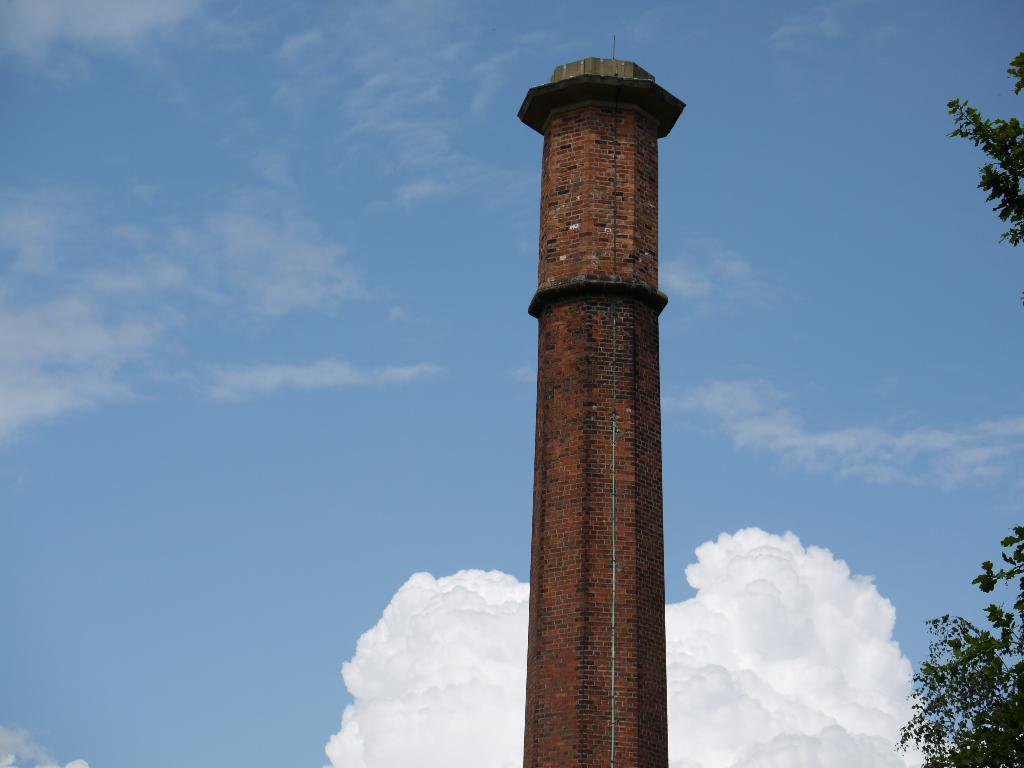Could you give a brief overview of what you see in this image? In the foreground of this image, there is a building tower and on the right, there is tree. In the background, there is the sky and the cloud. 